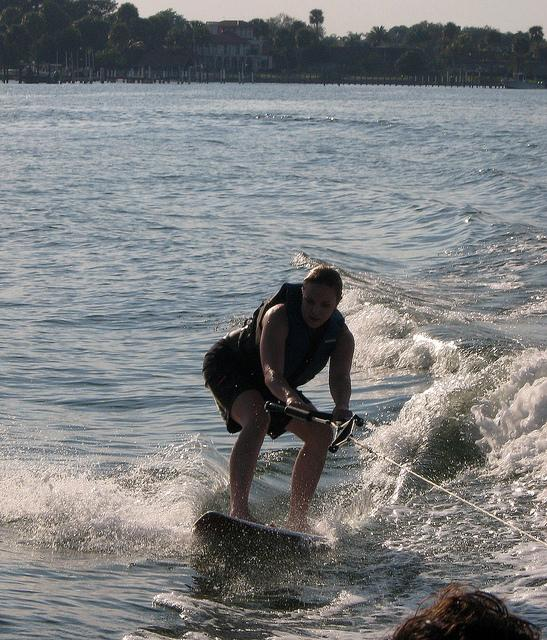What form of exercise is this? skiing 